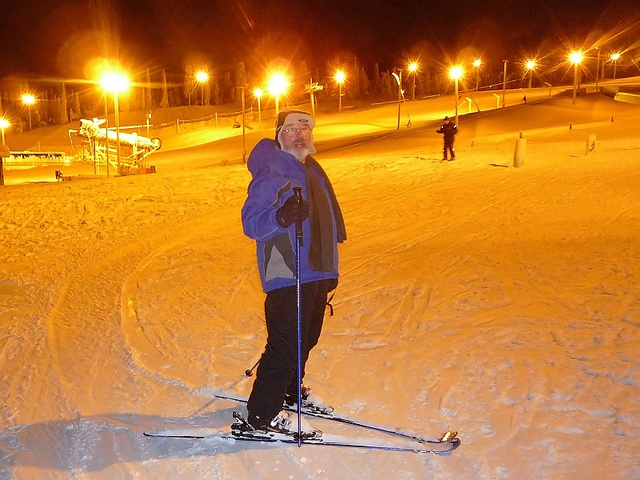Describe the objects in this image and their specific colors. I can see people in black, maroon, and purple tones, skis in black, tan, darkgray, and lightgray tones, and people in black, maroon, brown, and orange tones in this image. 